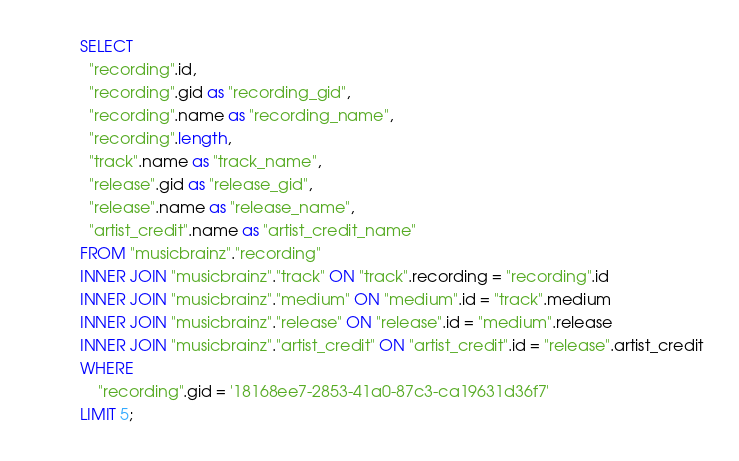<code> <loc_0><loc_0><loc_500><loc_500><_SQL_>SELECT
  "recording".id,
  "recording".gid as "recording_gid",
  "recording".name as "recording_name",
  "recording".length,
  "track".name as "track_name",
  "release".gid as "release_gid",
  "release".name as "release_name",
  "artist_credit".name as "artist_credit_name"
FROM "musicbrainz"."recording"
INNER JOIN "musicbrainz"."track" ON "track".recording = "recording".id
INNER JOIN "musicbrainz"."medium" ON "medium".id = "track".medium
INNER JOIN "musicbrainz"."release" ON "release".id = "medium".release
INNER JOIN "musicbrainz"."artist_credit" ON "artist_credit".id = "release".artist_credit
WHERE
    "recording".gid = '18168ee7-2853-41a0-87c3-ca19631d36f7'
LIMIT 5;
</code> 